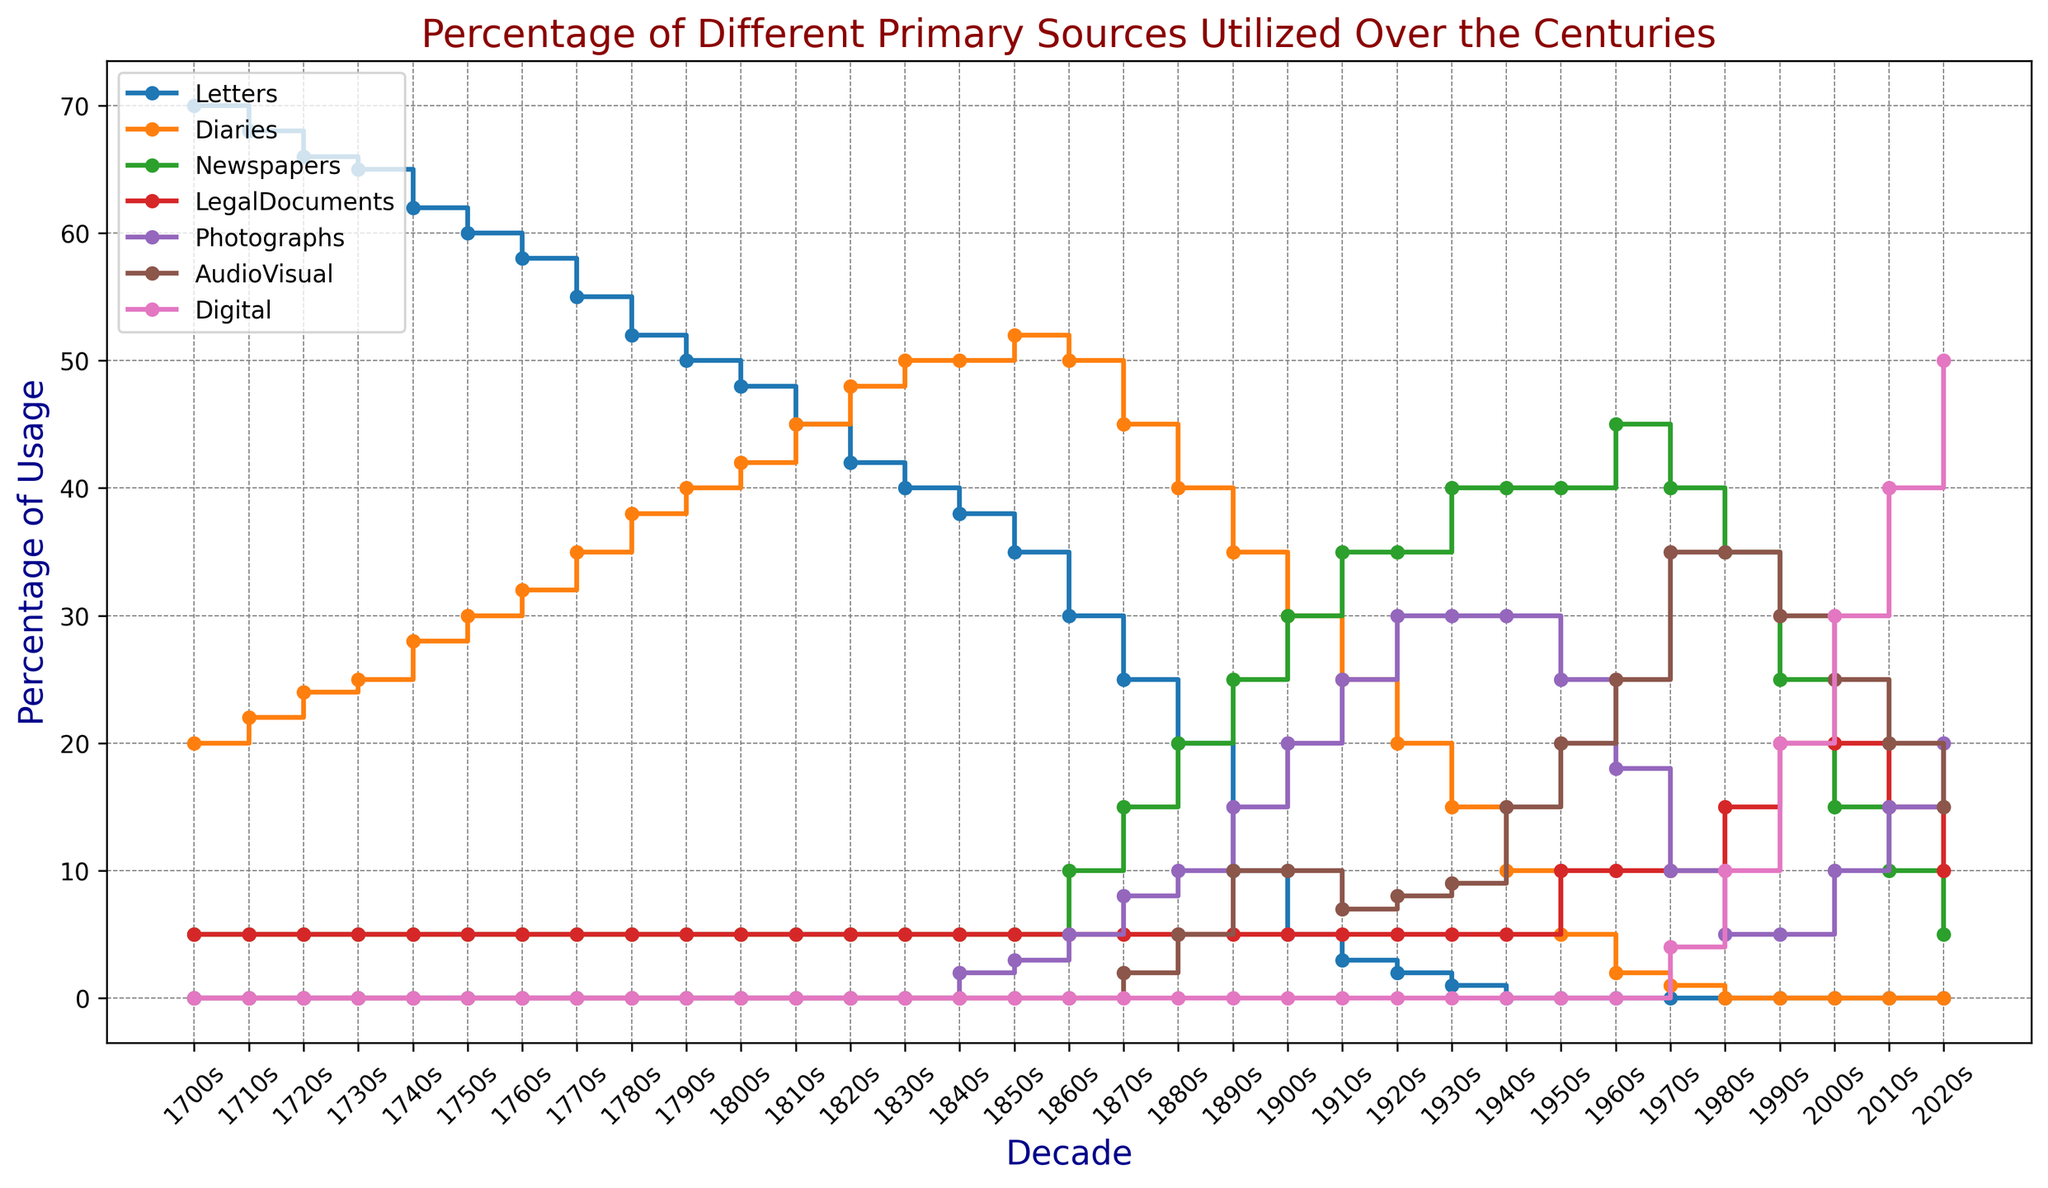Which primary source category saw the biggest increase in usage percentage from the 1880s to the 2020s? To find the biggest increase, we need to subtract the percentage in the 1880s from the percentage in the 2020s for each category. The differences are: Letters (0-20=-20), Diaries (0-40=-40), Newspapers (5-35=30), LegalDocuments (10-5=-5), Photographs (20-10=10), AudioVisual (15-5=10), Digital (50-0=50). The biggest increase is for Digital sources.
Answer: Digital (50%) Which three decades had the highest percentage usage of LegalDocuments? By observing the plot, the three decades with the highest usage of LegalDocuments are the 1950s, 1980s, and 1990s, all peaking at a usage of 20%.
Answer: 1950s, 1980s, 1990s What was the average percentage of Diaries usage in the 1700s? In the 1700s, the decades are the 1700s, 1710s, 1720s, 1730s, 1740s, 1750s, 1760s, 1770s, 1780s, and 1790s. The percentages are [20, 22, 24, 25, 28, 30, 32, 35, 38, 40]. The sum is 294. Dividing by 10, the average is 29.4%.
Answer: 29.4% During which decade did AudioVisual sources first appear? By checking the plot, the first appearance of AudioVisual sources is in the 1870s at 2%.
Answer: 1870s What is the sum of the usage percentages of Digital and AudioVisual sources in the 2010s? From the plot, Digital sources have a usage percentage of 40% and AudioVisual sources have 20% in the 2010s. The sum is 40% + 20% = 60%.
Answer: 60% In which decade did Newspapers surpass Letters in usage percentage? From the plot, Newspapers surpassed Letters in the 1930s. Newspapers were at 40% and Letters were at 1%.
Answer: 1930s By what percentage did the usage of Photographs change from the 1940s to the 1950s? In the 1940s, Photographs had a usage percentage of 30%. In the 1950s, it was 25%. The change is 25% - 30% = -5%. There was a 5% decrease.
Answer: -5% What is the difference in the usage percentage of Diaries between the 1800s and 1810s? In the 1800s, Diaries had a usage of 42% and in the 1810s, it was 45%. The difference is 45% - 42% = 3%.
Answer: 3% 